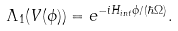<formula> <loc_0><loc_0><loc_500><loc_500>\Lambda _ { 1 } ( V ( \phi ) ) = e ^ { - i H _ { i n t } \phi / ( \hbar { \Omega } ) } . \,</formula> 